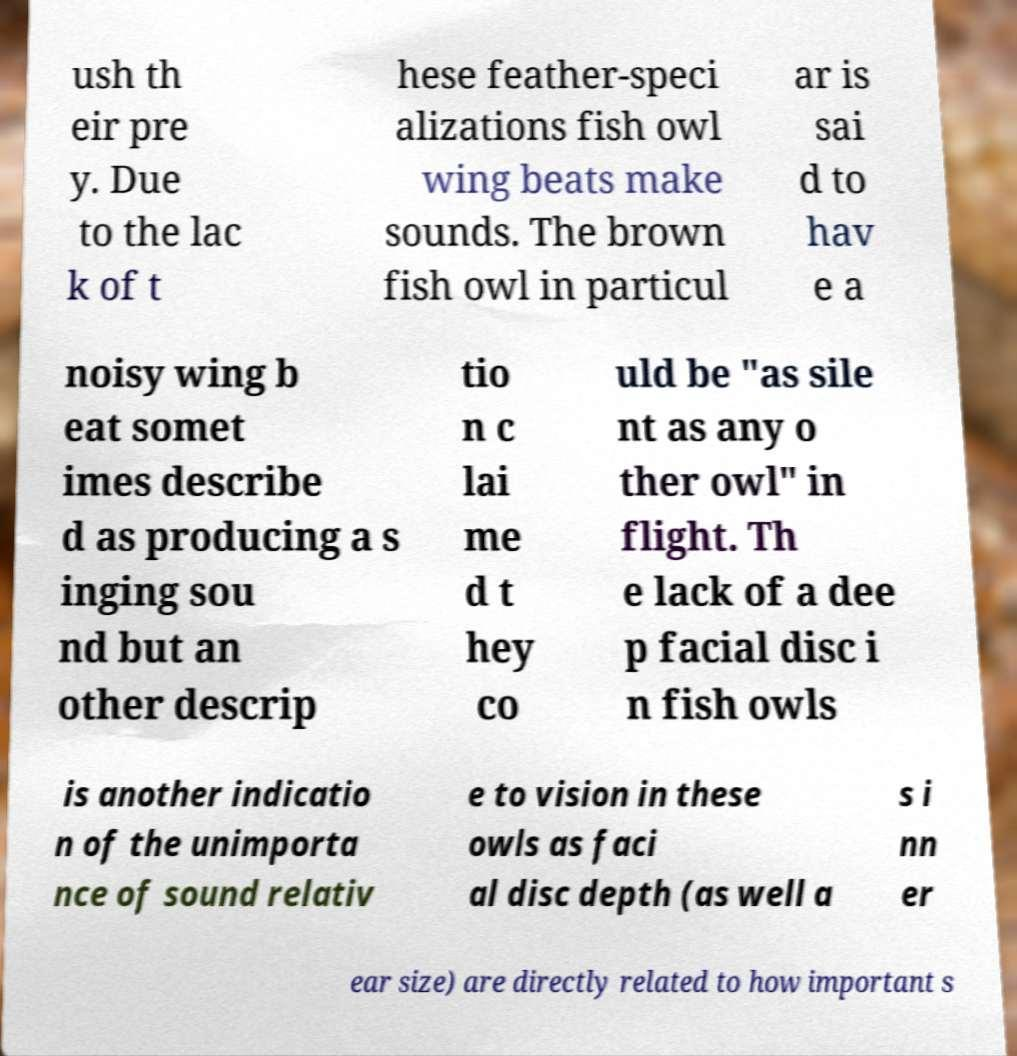I need the written content from this picture converted into text. Can you do that? ush th eir pre y. Due to the lac k of t hese feather-speci alizations fish owl wing beats make sounds. The brown fish owl in particul ar is sai d to hav e a noisy wing b eat somet imes describe d as producing a s inging sou nd but an other descrip tio n c lai me d t hey co uld be "as sile nt as any o ther owl" in flight. Th e lack of a dee p facial disc i n fish owls is another indicatio n of the unimporta nce of sound relativ e to vision in these owls as faci al disc depth (as well a s i nn er ear size) are directly related to how important s 